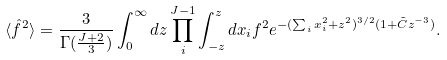<formula> <loc_0><loc_0><loc_500><loc_500>\langle \hat { f } ^ { 2 } \rangle = \frac { 3 } { \Gamma ( \frac { J + 2 } { 3 } ) } \int _ { 0 } ^ { \infty } d z \prod _ { i } ^ { J - 1 } \int _ { - z } ^ { z } d x _ { i } f ^ { 2 } e ^ { - ( \sum _ { i } x _ { i } ^ { 2 } + z ^ { 2 } ) ^ { 3 / 2 } ( 1 + \tilde { C } z ^ { - 3 } ) } .</formula> 